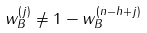Convert formula to latex. <formula><loc_0><loc_0><loc_500><loc_500>w _ { B } ^ { ( j ) } \neq 1 - w _ { B } ^ { ( n - h + j ) }</formula> 